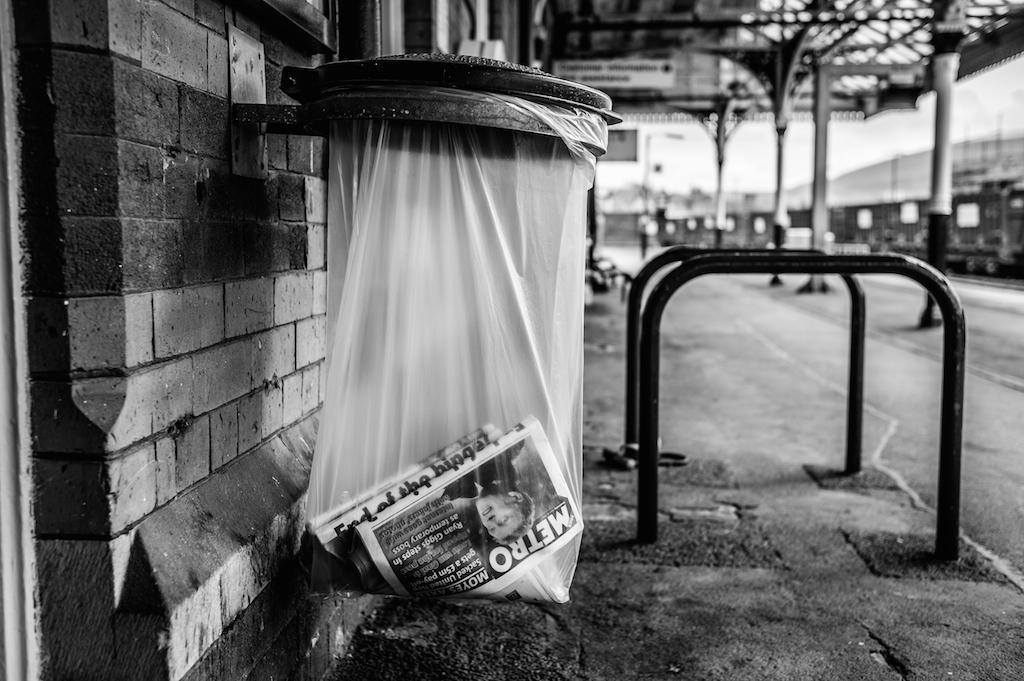<image>
Share a concise interpretation of the image provided. A black and white street scene with a Metro magazine in a trash can. 